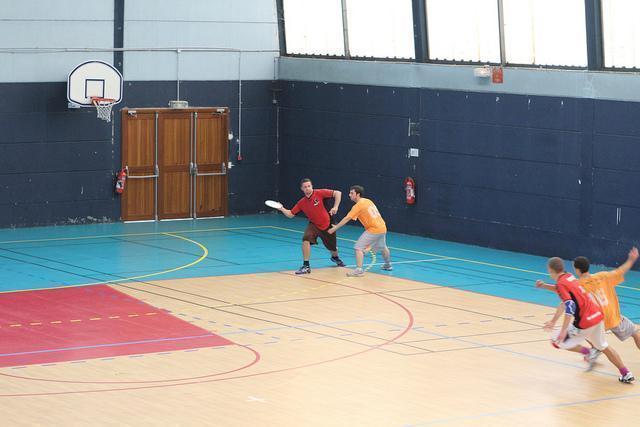What game is usually played on this court?
Select the accurate answer and provide explanation: 'Answer: answer
Rationale: rationale.'
Options: Badminton, tennis, basketball, volleyball. Answer: basketball.
Rationale: There is a hoop with a backboard and lines on the floor showing where to shoot from. 